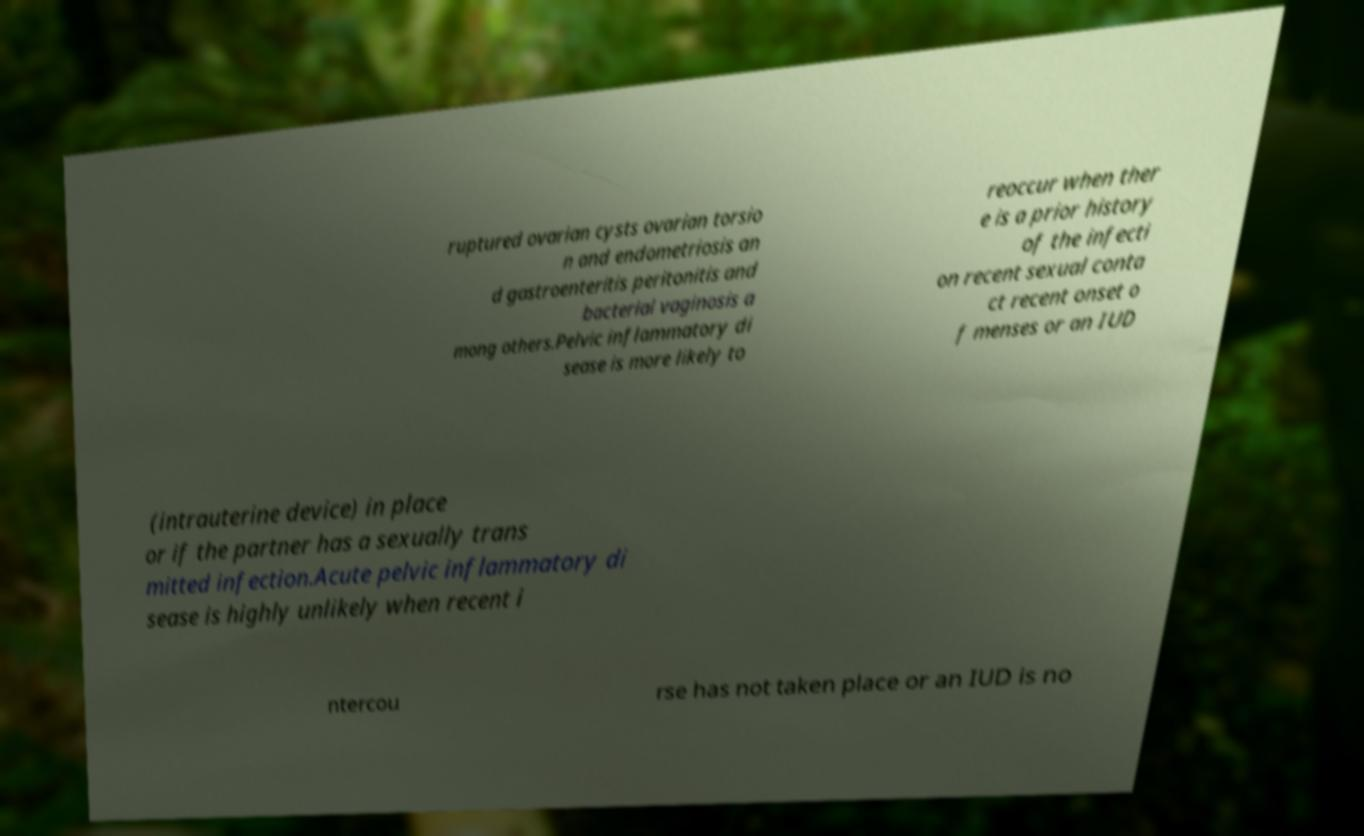There's text embedded in this image that I need extracted. Can you transcribe it verbatim? ruptured ovarian cysts ovarian torsio n and endometriosis an d gastroenteritis peritonitis and bacterial vaginosis a mong others.Pelvic inflammatory di sease is more likely to reoccur when ther e is a prior history of the infecti on recent sexual conta ct recent onset o f menses or an IUD (intrauterine device) in place or if the partner has a sexually trans mitted infection.Acute pelvic inflammatory di sease is highly unlikely when recent i ntercou rse has not taken place or an IUD is no 